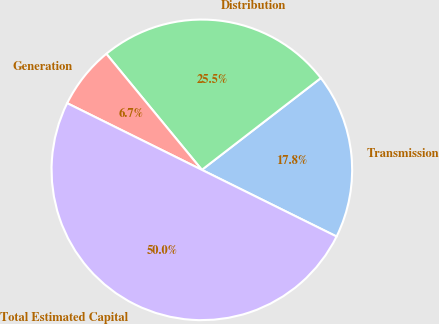Convert chart to OTSL. <chart><loc_0><loc_0><loc_500><loc_500><pie_chart><fcel>Transmission<fcel>Distribution<fcel>Generation<fcel>Total Estimated Capital<nl><fcel>17.77%<fcel>25.5%<fcel>6.72%<fcel>50.0%<nl></chart> 